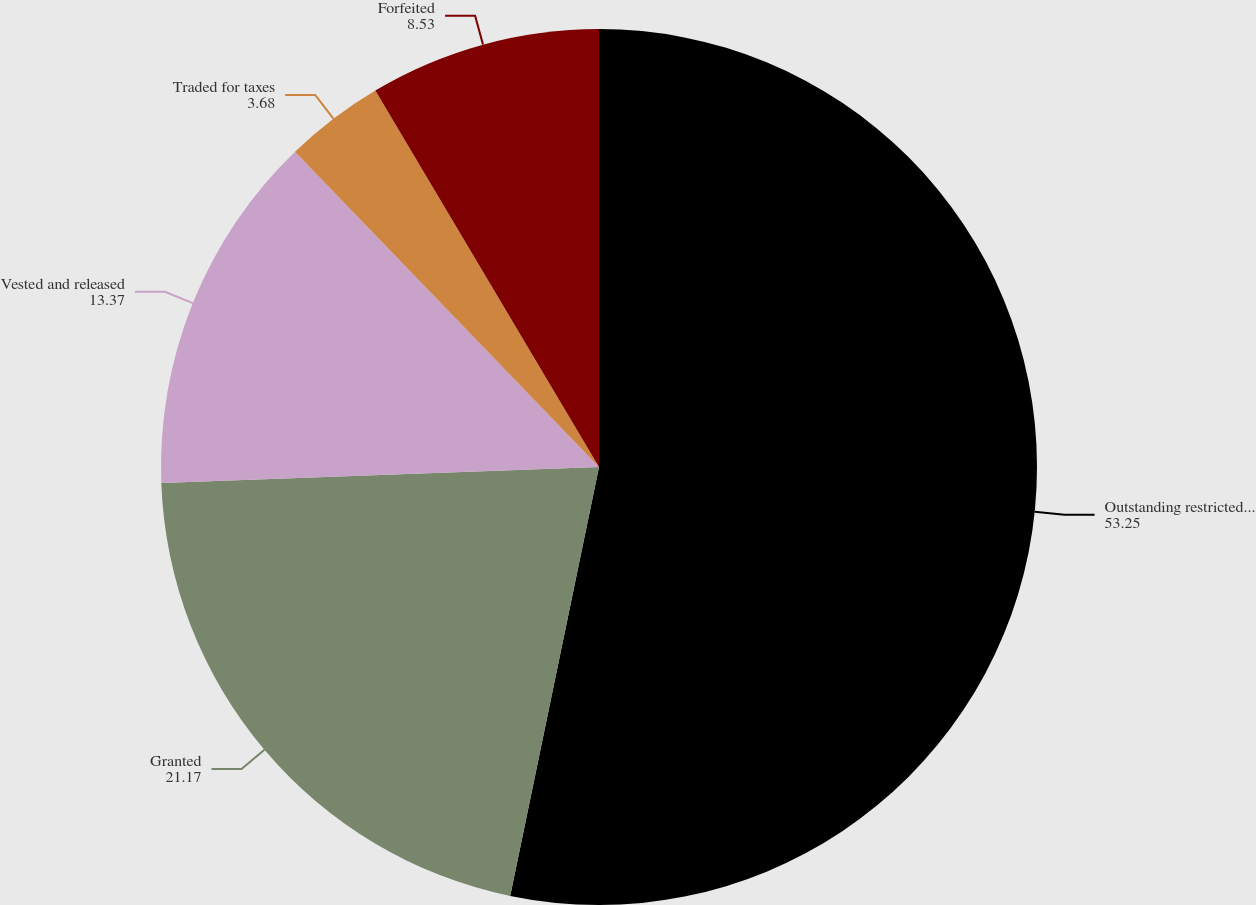<chart> <loc_0><loc_0><loc_500><loc_500><pie_chart><fcel>Outstanding restricted stock<fcel>Granted<fcel>Vested and released<fcel>Traded for taxes<fcel>Forfeited<nl><fcel>53.25%<fcel>21.17%<fcel>13.37%<fcel>3.68%<fcel>8.53%<nl></chart> 